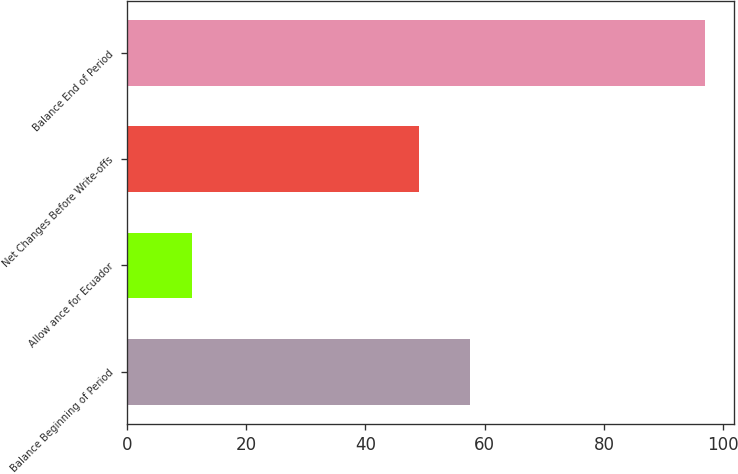<chart> <loc_0><loc_0><loc_500><loc_500><bar_chart><fcel>Balance Beginning of Period<fcel>Allow ance for Ecuador<fcel>Net Changes Before Write-offs<fcel>Balance End of Period<nl><fcel>57.6<fcel>11<fcel>49<fcel>97<nl></chart> 